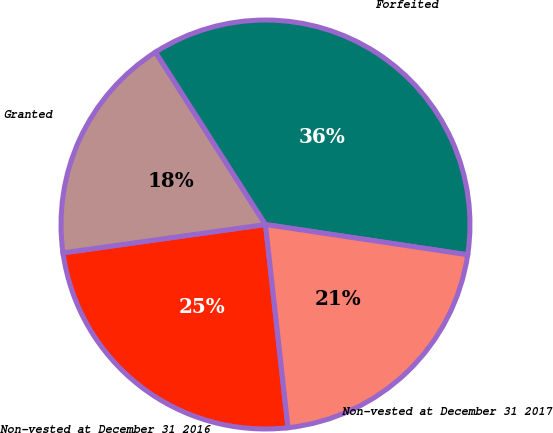Convert chart. <chart><loc_0><loc_0><loc_500><loc_500><pie_chart><fcel>Non-vested at December 31 2016<fcel>Granted<fcel>Forfeited<fcel>Non-vested at December 31 2017<nl><fcel>24.54%<fcel>18.18%<fcel>36.4%<fcel>20.88%<nl></chart> 